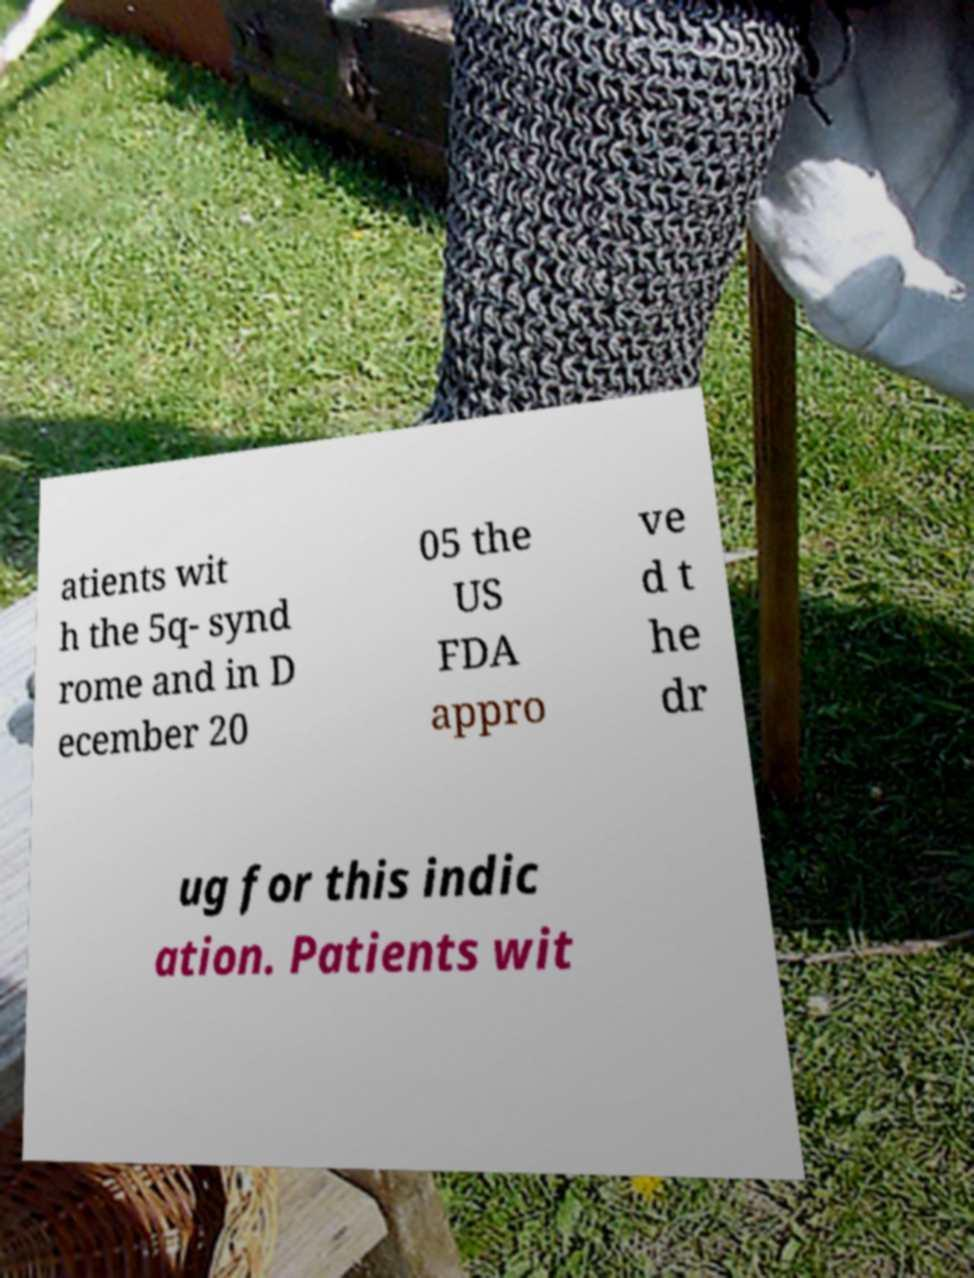Can you accurately transcribe the text from the provided image for me? atients wit h the 5q- synd rome and in D ecember 20 05 the US FDA appro ve d t he dr ug for this indic ation. Patients wit 